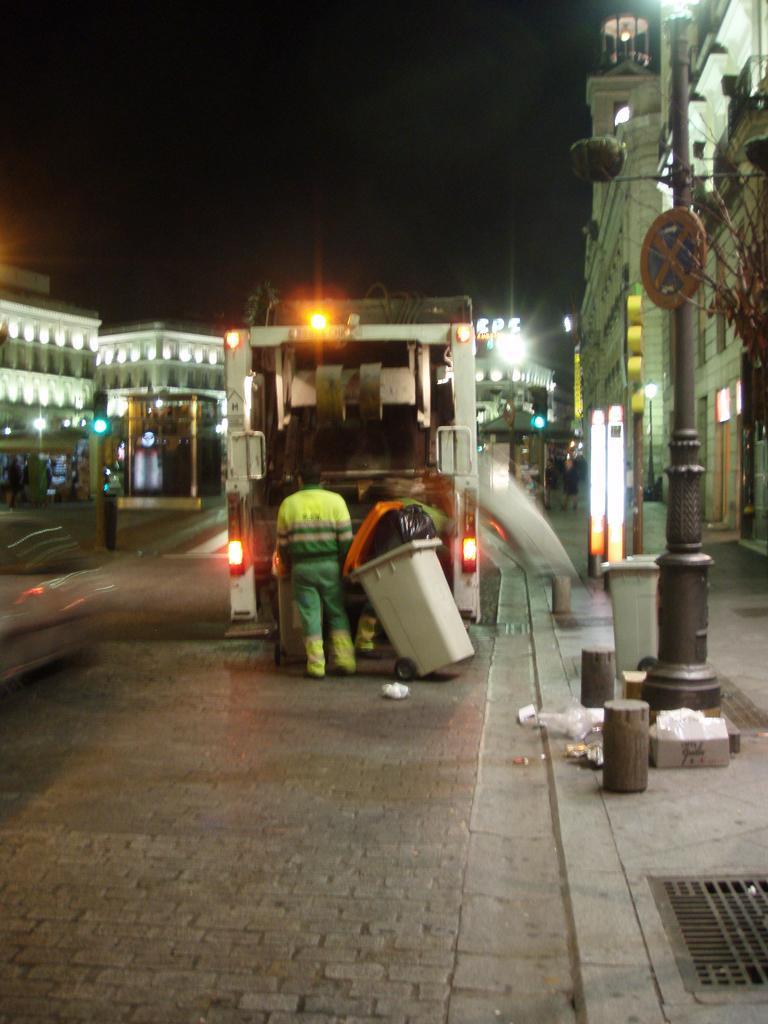Describe this image in one or two sentences. In this image there is a road, on that road there is a man standing, in front of the man there is a van and a dustbin on either side of the roads there are buildings and poles. 